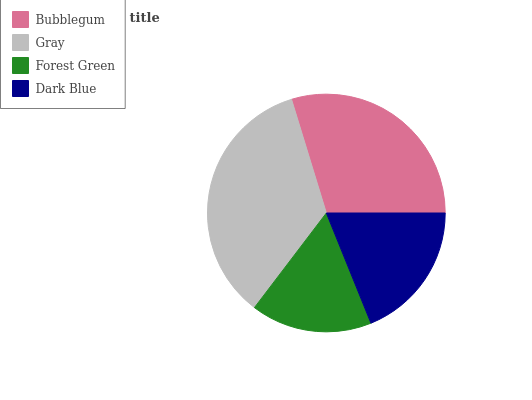Is Forest Green the minimum?
Answer yes or no. Yes. Is Gray the maximum?
Answer yes or no. Yes. Is Gray the minimum?
Answer yes or no. No. Is Forest Green the maximum?
Answer yes or no. No. Is Gray greater than Forest Green?
Answer yes or no. Yes. Is Forest Green less than Gray?
Answer yes or no. Yes. Is Forest Green greater than Gray?
Answer yes or no. No. Is Gray less than Forest Green?
Answer yes or no. No. Is Bubblegum the high median?
Answer yes or no. Yes. Is Dark Blue the low median?
Answer yes or no. Yes. Is Dark Blue the high median?
Answer yes or no. No. Is Bubblegum the low median?
Answer yes or no. No. 